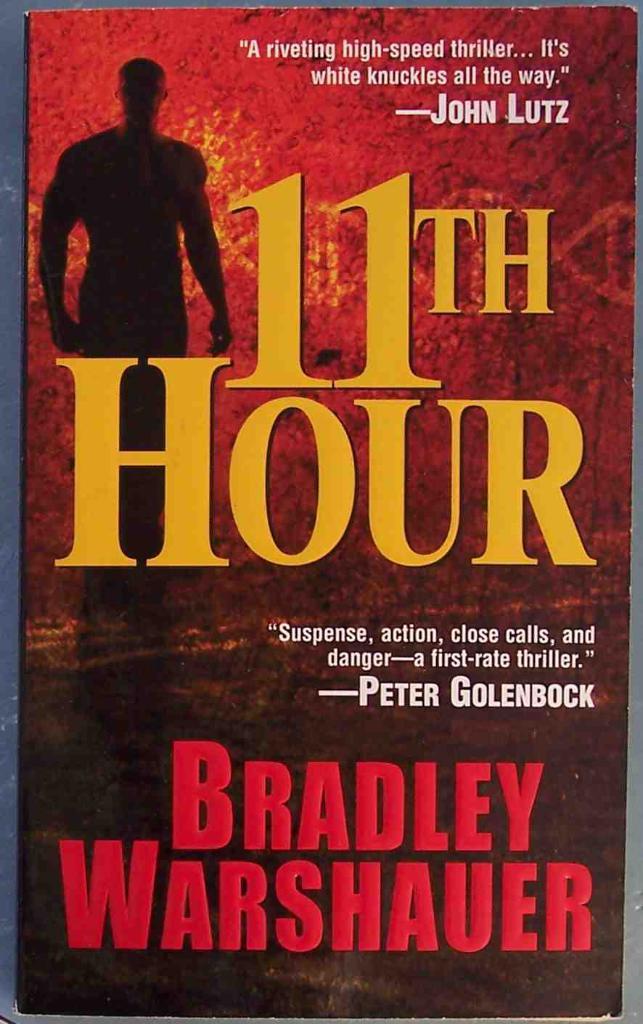What is peter's last name?
Make the answer very short. Golenbock. Who is the author of the book?
Your response must be concise. Bradley warshauer. 